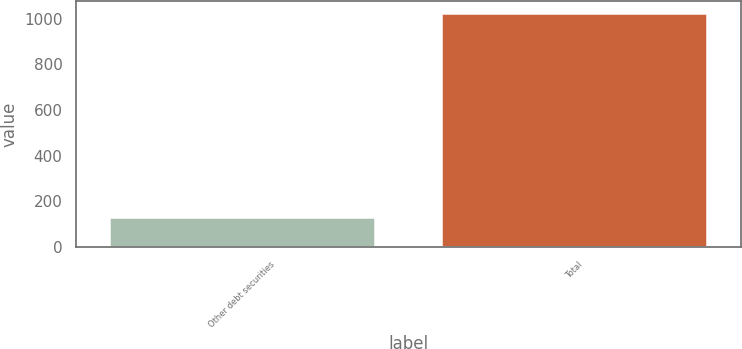Convert chart to OTSL. <chart><loc_0><loc_0><loc_500><loc_500><bar_chart><fcel>Other debt securities<fcel>Total<nl><fcel>131<fcel>1025.6<nl></chart> 